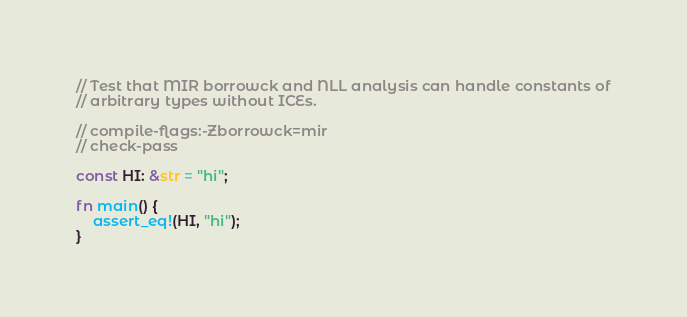<code> <loc_0><loc_0><loc_500><loc_500><_Rust_>// Test that MIR borrowck and NLL analysis can handle constants of
// arbitrary types without ICEs.

// compile-flags:-Zborrowck=mir
// check-pass

const HI: &str = "hi";

fn main() {
    assert_eq!(HI, "hi");
}
</code> 